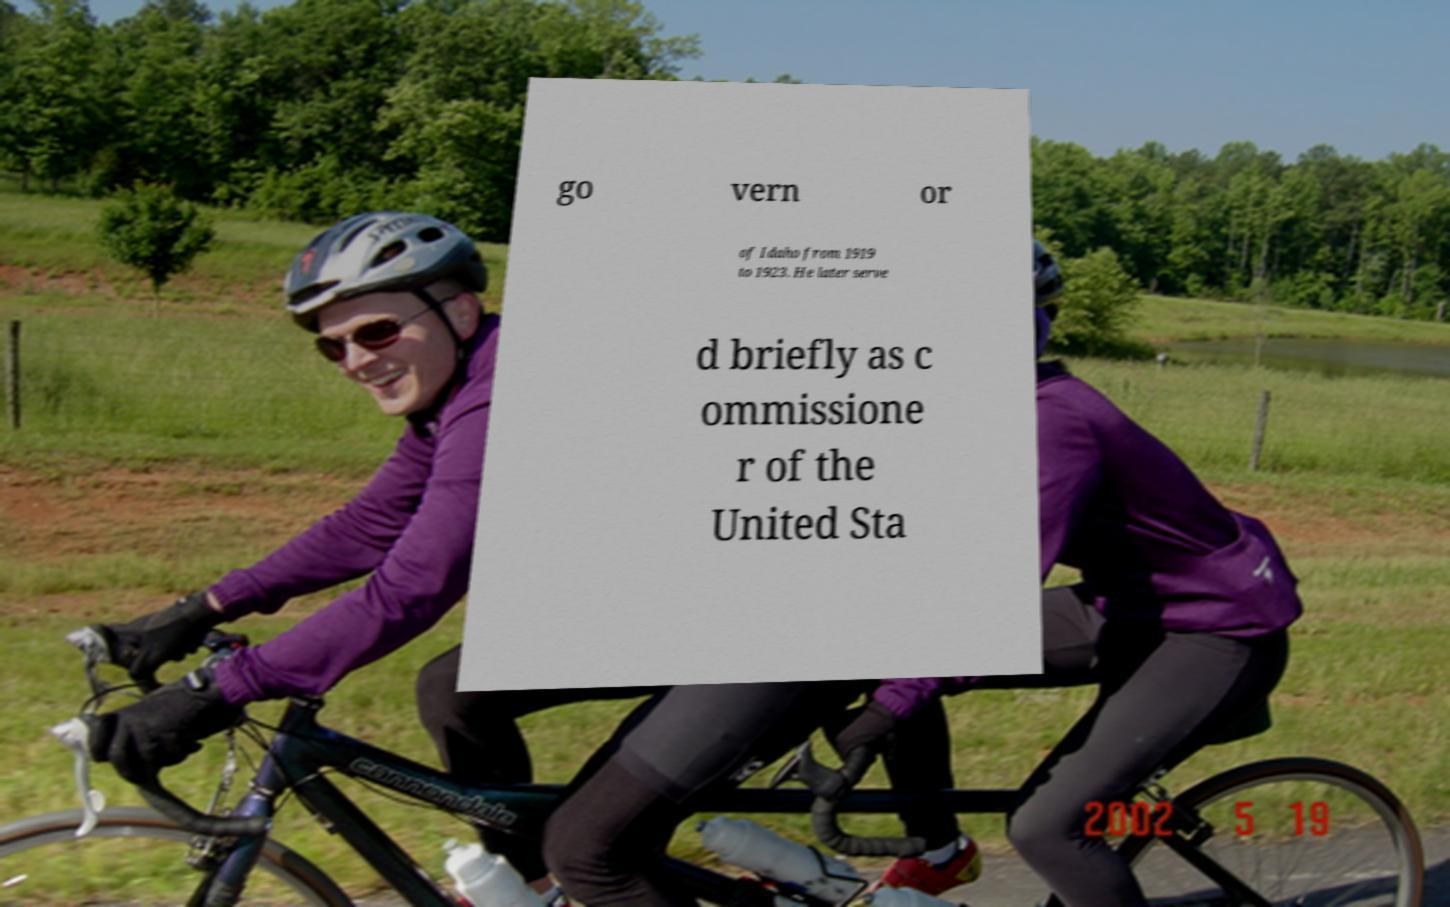There's text embedded in this image that I need extracted. Can you transcribe it verbatim? go vern or of Idaho from 1919 to 1923. He later serve d briefly as c ommissione r of the United Sta 